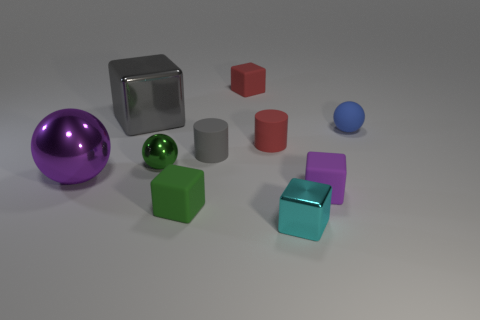There is a thing that is the same color as the big metallic block; what is its material?
Your answer should be very brief. Rubber. Are there any other things that have the same size as the green rubber thing?
Offer a terse response. Yes. Does the matte object behind the small blue thing have the same shape as the small metal object on the left side of the small cyan object?
Provide a short and direct response. No. Is the number of green metallic things that are on the left side of the green sphere less than the number of purple metal objects left of the purple matte object?
Provide a succinct answer. Yes. How many other objects are there of the same shape as the small purple matte object?
Offer a terse response. 4. The green object that is the same material as the small cyan cube is what shape?
Your response must be concise. Sphere. What is the color of the object that is both on the right side of the big cube and behind the small blue ball?
Your response must be concise. Red. Is the material of the object right of the small purple cube the same as the cyan cube?
Your answer should be very brief. No. Is the number of cylinders in front of the small purple block less than the number of purple things?
Provide a short and direct response. Yes. Are there any other tiny balls that have the same material as the green sphere?
Provide a succinct answer. No. 